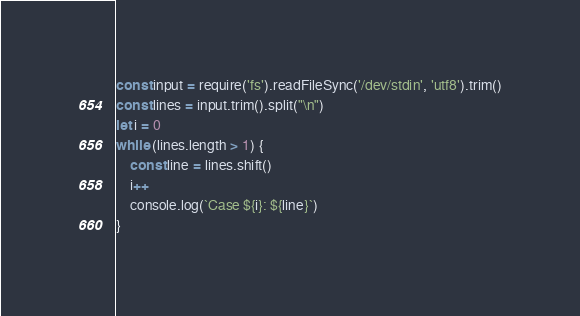Convert code to text. <code><loc_0><loc_0><loc_500><loc_500><_JavaScript_>const input = require('fs').readFileSync('/dev/stdin', 'utf8').trim()
const lines = input.trim().split("\n")
let i = 0
while (lines.length > 1) {
    const line = lines.shift()
    i++
    console.log(`Case ${i}: ${line}`)
}
</code> 